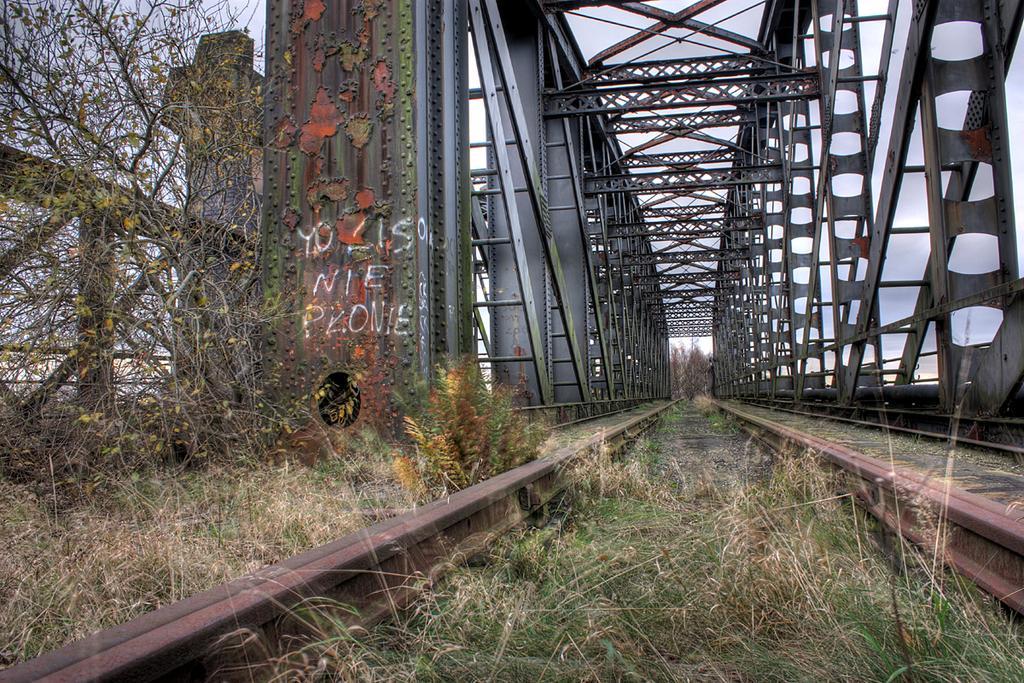In one or two sentences, can you explain what this image depicts? In the foreground of the picture there are plants, grass, railing and railway track. In the middle of the picture we can see iron frames. In the background there are trees. At the top there is sky. 